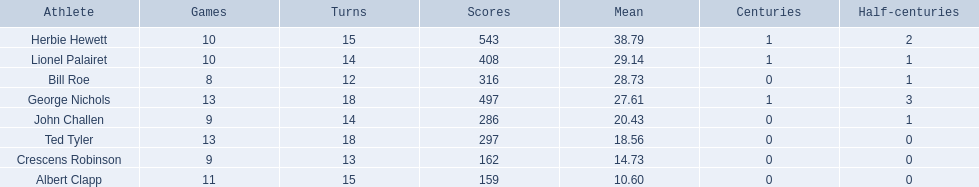Who are all of the players? Herbie Hewett, Lionel Palairet, Bill Roe, George Nichols, John Challen, Ted Tyler, Crescens Robinson, Albert Clapp. How many innings did they play in? 15, 14, 12, 18, 14, 18, 13, 15. Which player was in fewer than 13 innings? Bill Roe. 